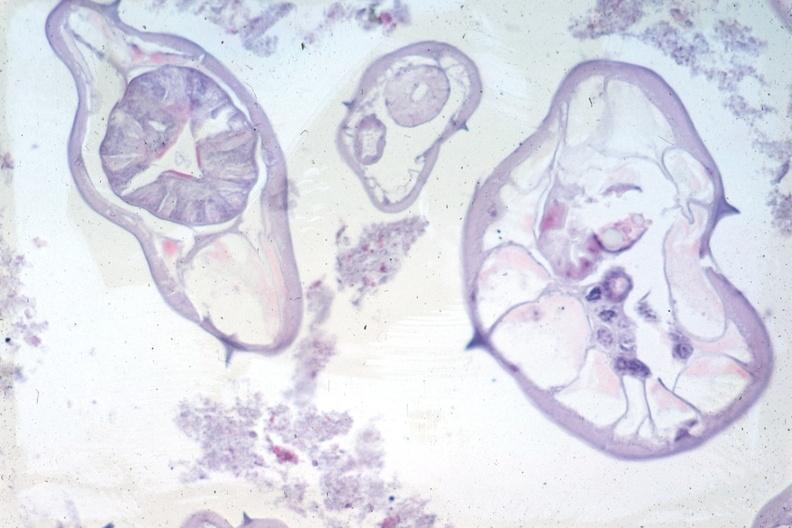where is this from?
Answer the question using a single word or phrase. Gastrointestinal system 